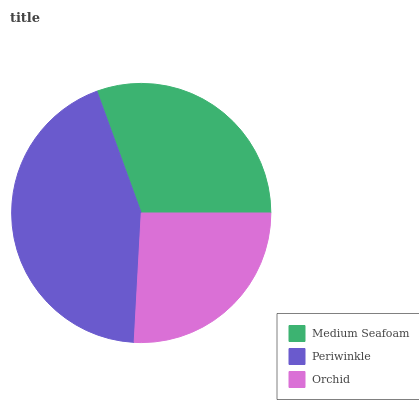Is Orchid the minimum?
Answer yes or no. Yes. Is Periwinkle the maximum?
Answer yes or no. Yes. Is Periwinkle the minimum?
Answer yes or no. No. Is Orchid the maximum?
Answer yes or no. No. Is Periwinkle greater than Orchid?
Answer yes or no. Yes. Is Orchid less than Periwinkle?
Answer yes or no. Yes. Is Orchid greater than Periwinkle?
Answer yes or no. No. Is Periwinkle less than Orchid?
Answer yes or no. No. Is Medium Seafoam the high median?
Answer yes or no. Yes. Is Medium Seafoam the low median?
Answer yes or no. Yes. Is Periwinkle the high median?
Answer yes or no. No. Is Orchid the low median?
Answer yes or no. No. 